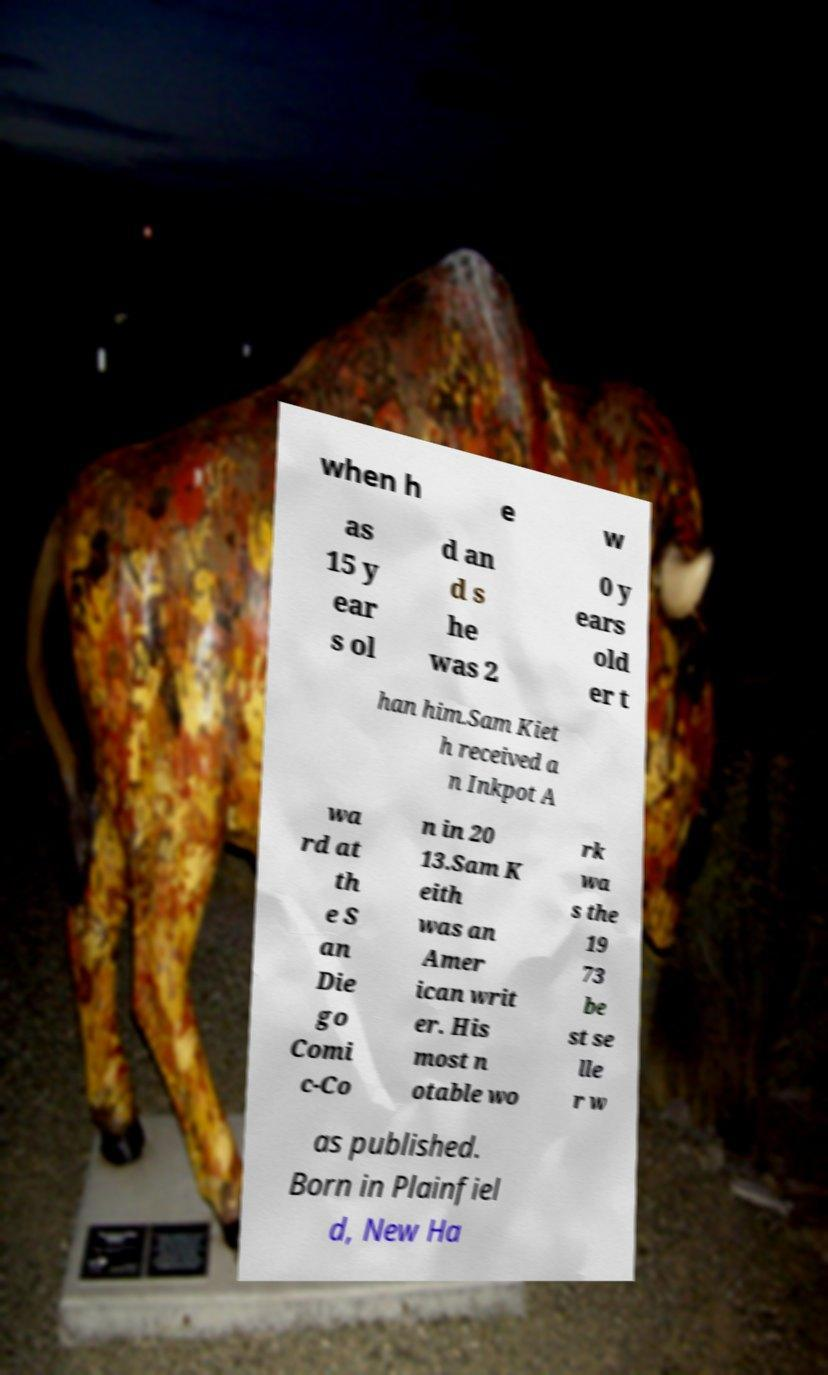Can you read and provide the text displayed in the image?This photo seems to have some interesting text. Can you extract and type it out for me? when h e w as 15 y ear s ol d an d s he was 2 0 y ears old er t han him.Sam Kiet h received a n Inkpot A wa rd at th e S an Die go Comi c-Co n in 20 13.Sam K eith was an Amer ican writ er. His most n otable wo rk wa s the 19 73 be st se lle r w as published. Born in Plainfiel d, New Ha 